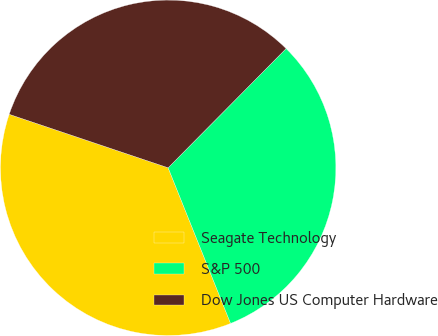<chart> <loc_0><loc_0><loc_500><loc_500><pie_chart><fcel>Seagate Technology<fcel>S&P 500<fcel>Dow Jones US Computer Hardware<nl><fcel>36.24%<fcel>31.51%<fcel>32.25%<nl></chart> 